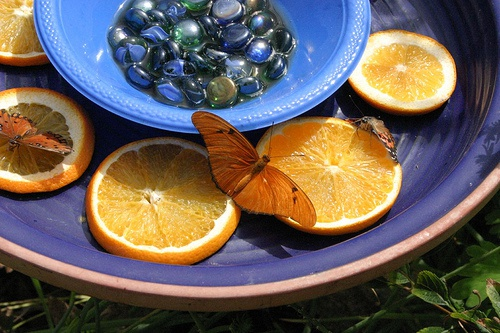Describe the objects in this image and their specific colors. I can see bowl in tan, lightblue, black, and gray tones, orange in tan, gold, orange, olive, and maroon tones, orange in tan, gold, orange, and red tones, orange in tan, maroon, and brown tones, and orange in tan, gold, khaki, beige, and orange tones in this image. 